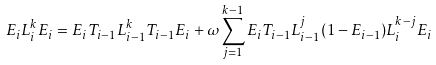<formula> <loc_0><loc_0><loc_500><loc_500>E _ { i } L _ { i } ^ { k } E _ { i } = E _ { i } T _ { i - 1 } L _ { i - 1 } ^ { k } T _ { i - 1 } E _ { i } + \omega \sum _ { j = 1 } ^ { k - 1 } E _ { i } T _ { i - 1 } L _ { i - 1 } ^ { j } ( 1 - E _ { i - 1 } ) L _ { i } ^ { k - j } E _ { i }</formula> 